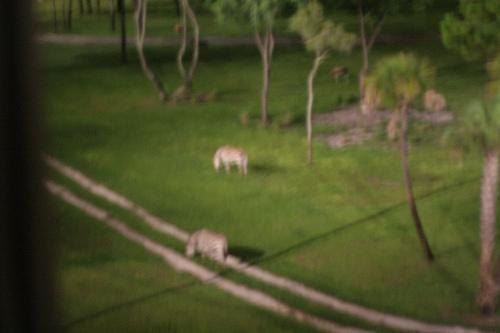How many animals are there?
Give a very brief answer. 2. 